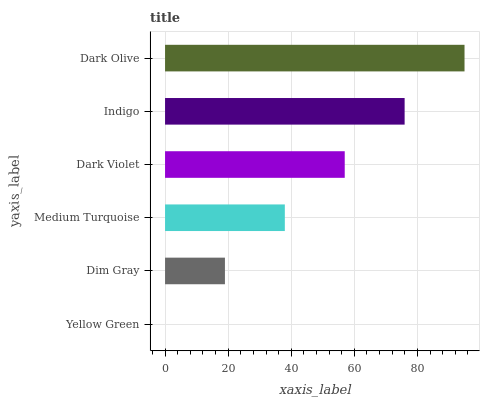Is Yellow Green the minimum?
Answer yes or no. Yes. Is Dark Olive the maximum?
Answer yes or no. Yes. Is Dim Gray the minimum?
Answer yes or no. No. Is Dim Gray the maximum?
Answer yes or no. No. Is Dim Gray greater than Yellow Green?
Answer yes or no. Yes. Is Yellow Green less than Dim Gray?
Answer yes or no. Yes. Is Yellow Green greater than Dim Gray?
Answer yes or no. No. Is Dim Gray less than Yellow Green?
Answer yes or no. No. Is Dark Violet the high median?
Answer yes or no. Yes. Is Medium Turquoise the low median?
Answer yes or no. Yes. Is Dark Olive the high median?
Answer yes or no. No. Is Yellow Green the low median?
Answer yes or no. No. 